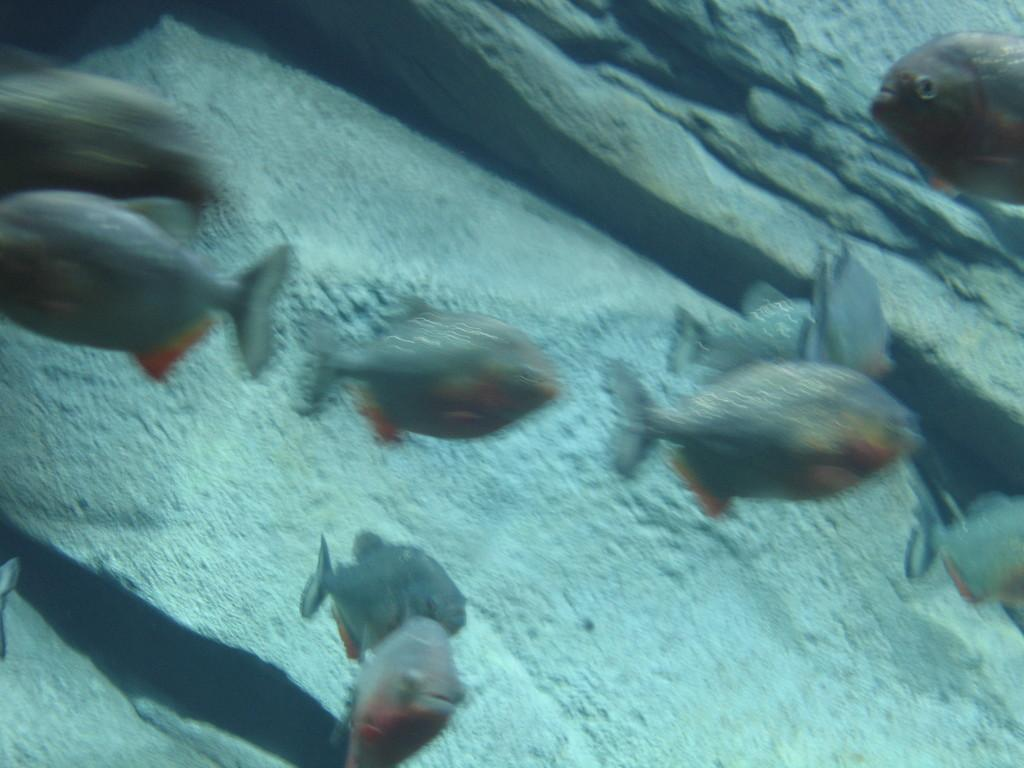What type of animals can be seen in the image? There are fishes in the image. Where are the fishes located? The fishes are under water. What year does the agreement between the fishes and the hill take place in the image? There is no agreement between the fishes and a hill in the image, nor is there any reference to a specific year. 